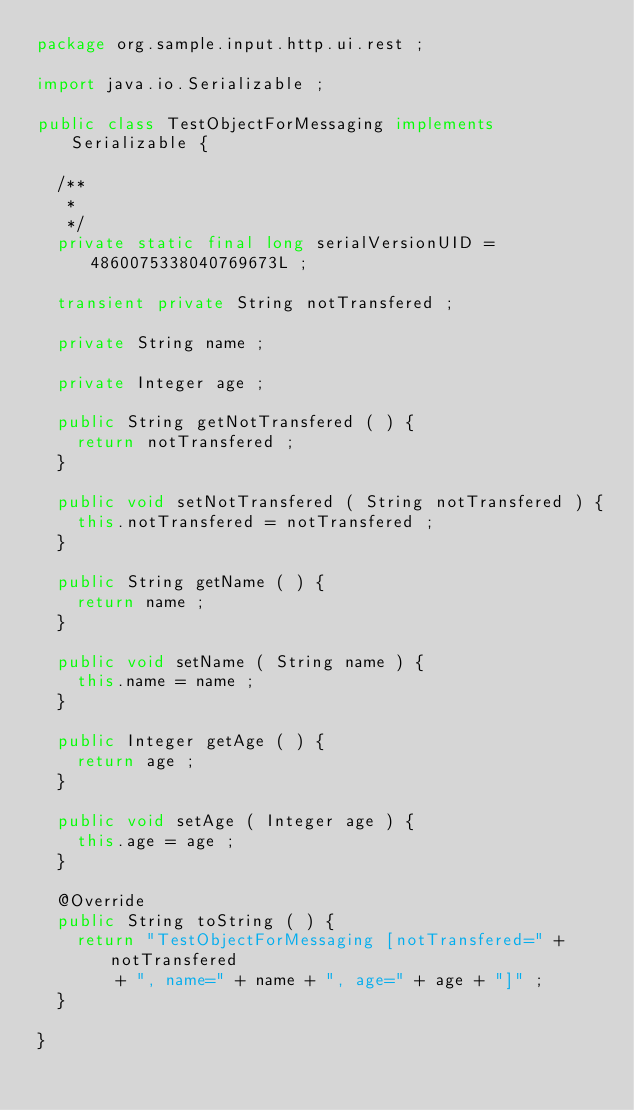Convert code to text. <code><loc_0><loc_0><loc_500><loc_500><_Java_>package org.sample.input.http.ui.rest ;

import java.io.Serializable ;

public class TestObjectForMessaging implements Serializable {

	/**
	 * 
	 */
	private static final long serialVersionUID = 4860075338040769673L ;

	transient private String notTransfered ;

	private String name ;

	private Integer age ;

	public String getNotTransfered ( ) {
		return notTransfered ;
	}

	public void setNotTransfered ( String notTransfered ) {
		this.notTransfered = notTransfered ;
	}

	public String getName ( ) {
		return name ;
	}

	public void setName ( String name ) {
		this.name = name ;
	}

	public Integer getAge ( ) {
		return age ;
	}

	public void setAge ( Integer age ) {
		this.age = age ;
	}

	@Override
	public String toString ( ) {
		return "TestObjectForMessaging [notTransfered=" + notTransfered
				+ ", name=" + name + ", age=" + age + "]" ;
	}

}
</code> 